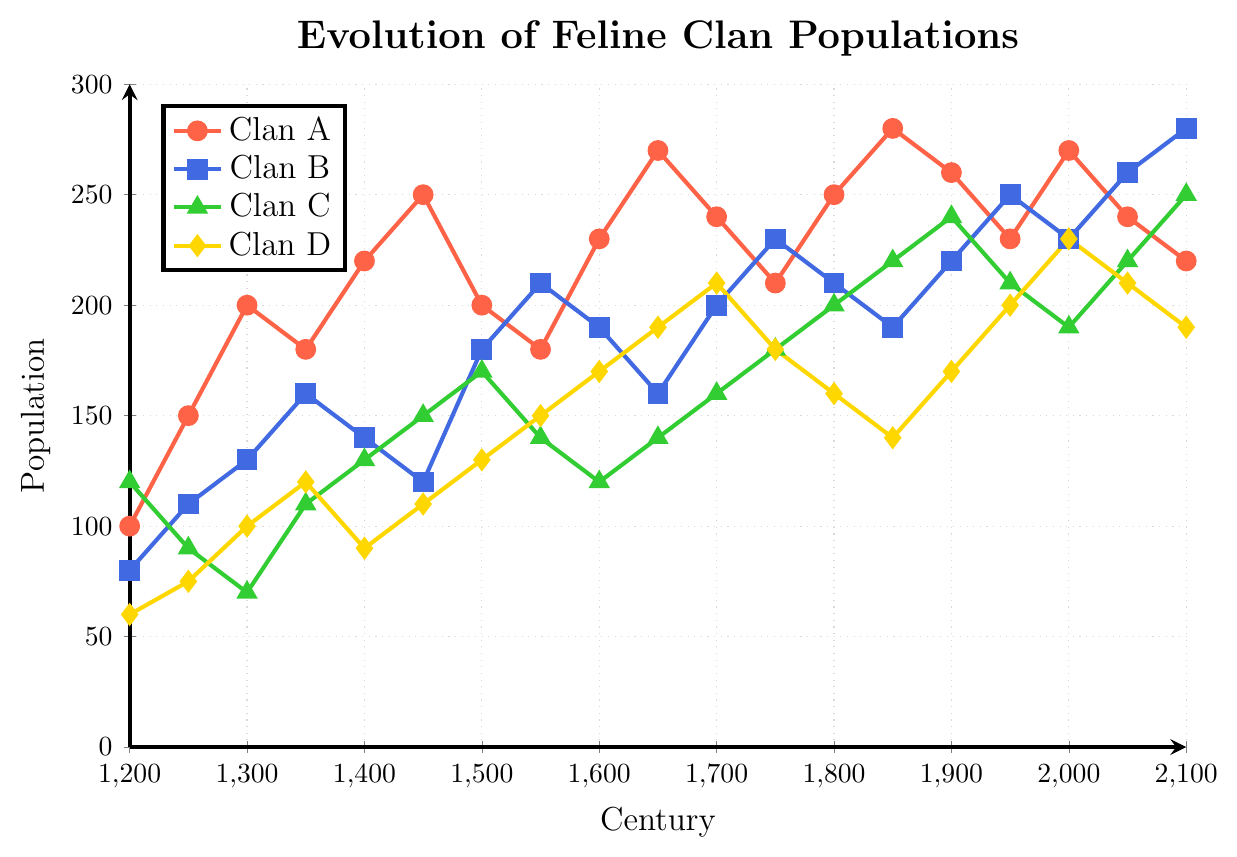Which clan had the highest population in the year 1650? To find the highest population in 1650, we check the population values for each clan in that year. Clan A had 270, Clan B had 160, Clan C had 140, and Clan D had 190. The highest value is 270.
Answer: Clan A Which clan experienced the steepest increase in population between the years 1500 and 1550? To determine the steepest increase, we calculate the population difference for each clan between 1500 and 1550 and compare the results. Clan A: 180-200 = -20, Clan B: 210-180 = 30, Clan C: 140-170 = -30, Clan D: 150-130 = 20. The steepest increase is 30.
Answer: Clan B How many clans saw a population decrease from 1450 to 1500? We evaluate the population changes from 1450 to 1500 for each clan. Clan A: 200-250 = -50, Clan B: 180-120 = 60, Clan C: 170-150 = 20, Clan D: 130-110 = 20. The clans with a decrease are Clan A.
Answer: 1 Which century showed the highest overall combined population of all clans? To find this, we sum the populations for each century and determine the total. For example, for 1650: 270+160+140+190 = 760. Applying this to all centuries, the highest total population is 780 in 1900.
Answer: 1900 What was the population trend for Clan C between 2000 and 2100? To identify the trend, we observe the changes in population at the given intervals. Clan C's population changes were 190 in 2000, 220 in 2050, and 250 in 2100. This shows a general increase over the century.
Answer: Increase Which clan reached a population of 250 first over the centuries? Observing the line chart, Clan A first reaches a population of 250 in the year 1850. Clan B, Clan C, and Clan D reached 250 afterwards or not at all.
Answer: Clan A In which century did Clan D have the most significant population boom? Analyzing the changes for Clan D, we find the greatest increase from 1250 (75) to 1300 (100), which is 25 in the 13th century.
Answer: 13th century By how much did the population of Clan A change from its highest to its lowest point? Clan A's highest population is 280 (1850), and its lowest is 100 (1200). The change is calculated as 280 - 100 = 180.
Answer: 180 How did the populations of Clan B and Clan D compare in the year 2000? For the year 2000, Clan B had a population of 230, and Clan D had 230. Both populations are identical.
Answer: Equal What is the sum of the populations of Clan A and Clan C in the year 2100? In 2100, Clan A's population is 220 and Clan C's is 250. Adding these populations gives 220 + 250 = 470.
Answer: 470 